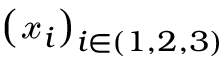<formula> <loc_0><loc_0><loc_500><loc_500>\left ( \ m a t h s c r { x } _ { i } \right ) _ { i \in ( 1 , 2 , 3 ) }</formula> 